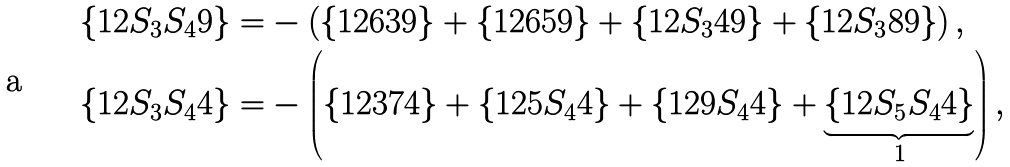Convert formula to latex. <formula><loc_0><loc_0><loc_500><loc_500>\{ 1 2 S _ { 3 } S _ { 4 } 9 \} = & - \left ( \{ 1 2 6 3 9 \} + \{ 1 2 6 5 9 \} + \{ 1 2 S _ { 3 } 4 9 \} + \{ 1 2 S _ { 3 } 8 9 \} \right ) , \\ \{ 1 2 S _ { 3 } S _ { 4 } 4 \} = & - \left ( \{ 1 2 3 7 4 \} + \{ 1 2 5 S _ { 4 } 4 \} + \{ 1 2 9 S _ { 4 } 4 \} + \underbrace { \{ 1 2 S _ { 5 } S _ { 4 } 4 \} } _ { 1 } \right ) ,</formula> 